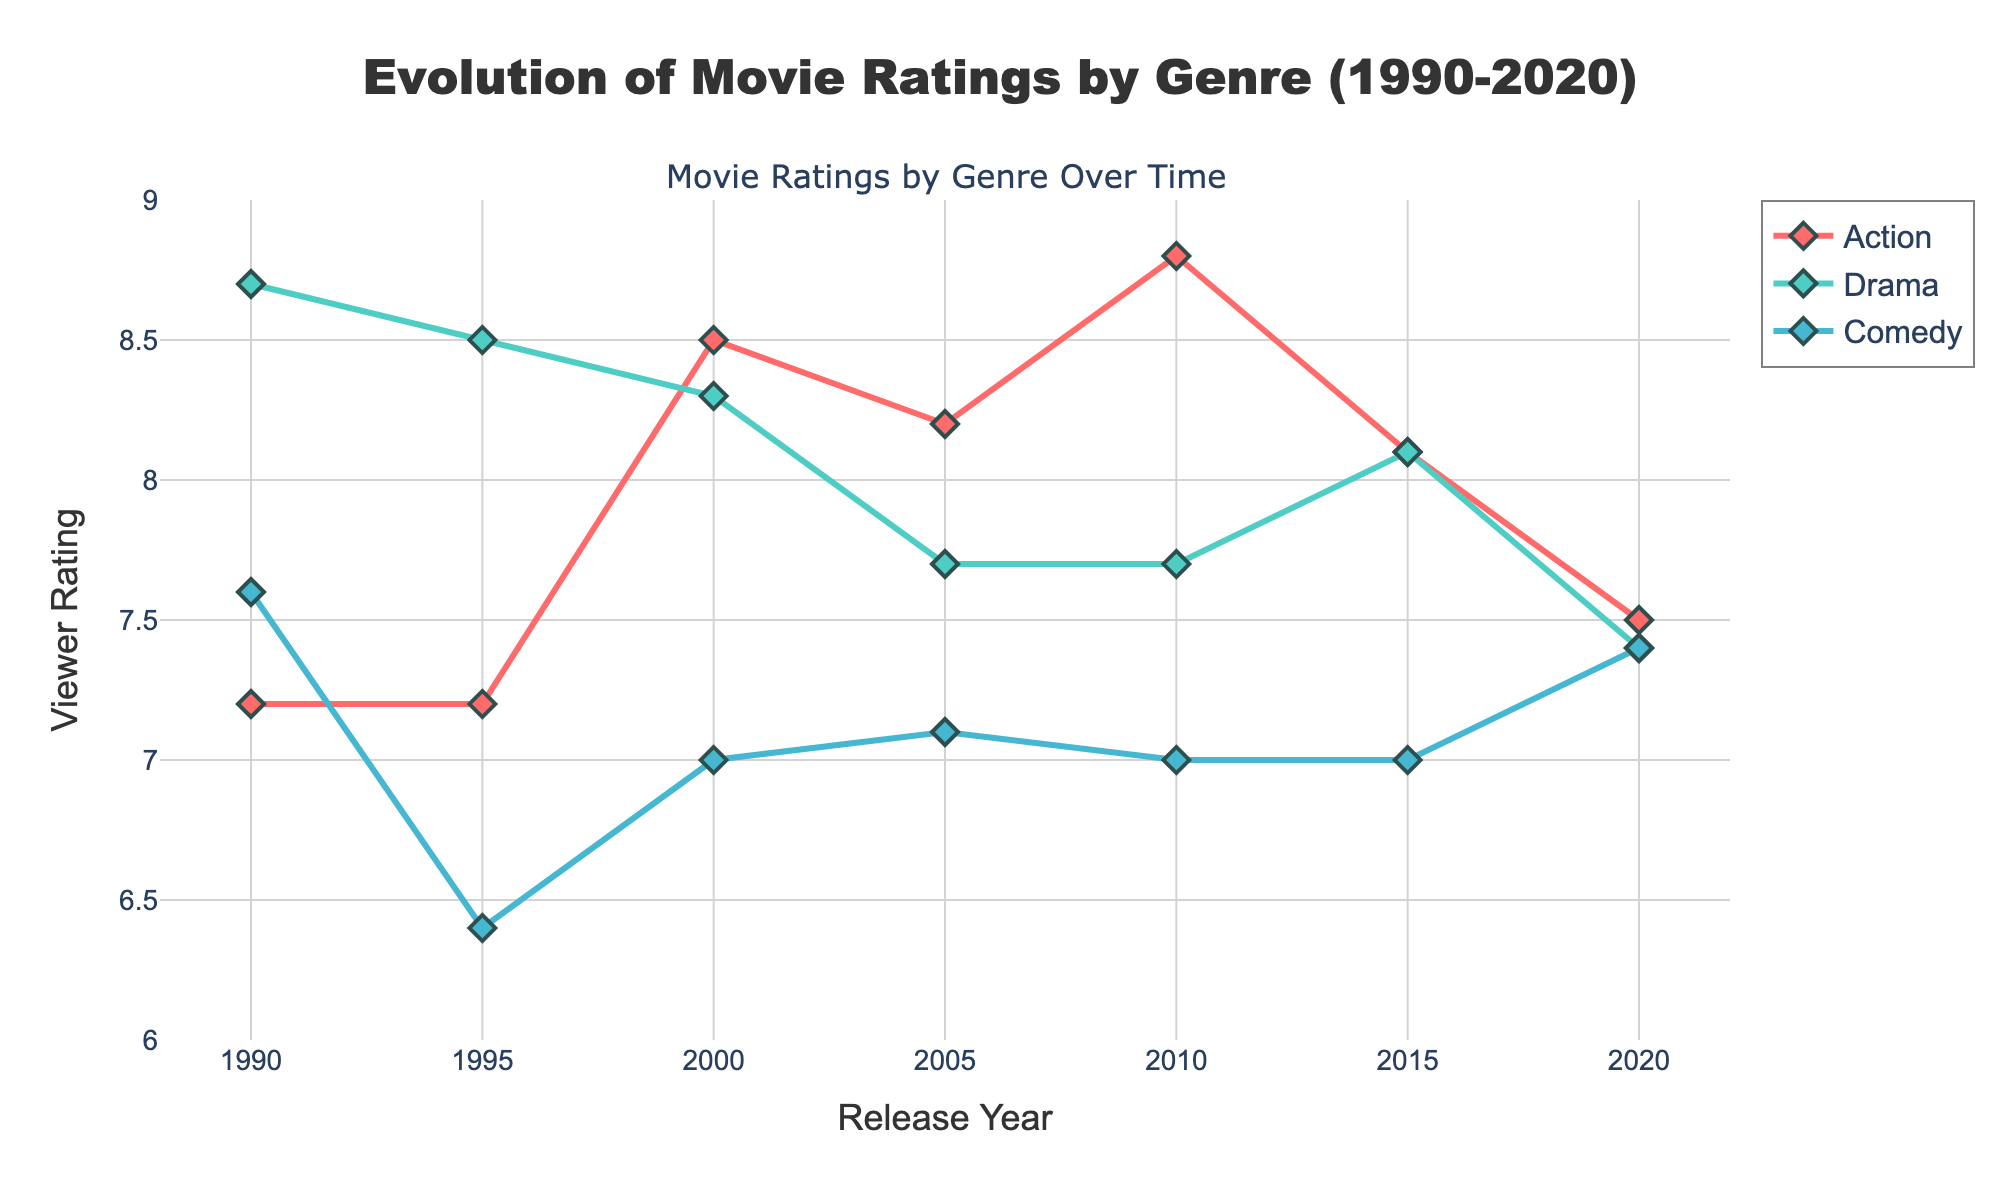What genres are being compared in the plot? The plot shows viewer ratings for three genres: Action, Drama, and Comedy.
Answer: Action, Drama, Comedy Which genre has the highest viewer rating overall? By checking the maximum y-values (viewer ratings) for each genre, Action has the highest rating, with the movie "Inception" at 8.8.
Answer: Action What is the average viewer rating for Drama movies in 2005? Based on the figure, the Drama movies from 2005 are represented by "Brokeback Mountain" with a rating of 7.7. Since there is only one Drama movie from that year, the average rating is 7.7.
Answer: 7.7 Between 1995 and 2020, which genre shows the most consistent viewer ratings, meaning the least variation? By observing the plot, Comedy movies display the least variation in ratings over the years. Their ratings remain around the 7.0 mark consistently.
Answer: Comedy How do Drama movies' ratings in 1990 compare to those in 2020? In 1990, Drama has a rating with "Goodfellas" at 8.7, while in 2020, Drama is represented by "Never Rarely Sometimes Always" with a rating of 7.4. The rating has decreased from 8.7 to 7.4.
Answer: Decreased What is the trend in viewer ratings for Action movies from 1990 to 2020? The viewer ratings for Action movies show a general increase from 1990 ("Die Hard 2" at 7.2) to 2020 ("Tenet" at 7.5), peaking with "Inception" in 2010 at 8.8.
Answer: Generally increasing Which year shows the highest-rated Comedy movie? From the plot, the highest-rated Comedy movie year is 1990, with "Home Alone" rated at 7.6.
Answer: 1990 How many movies are plotted in total for all genres combined? By counting the data points on the plot, there are 2 movies each plotted per year for 6 different years (1990, 1995, 2000, 2005, 2010, 2015, 2020), amounting to a total of 18 movies (6*3=18).
Answer: 18 What is the viewer rating range for Action movies on the plot? The viewer ratings for Action movies range from 7.2 ("Die Hard 2" in 1990 and "GoldenEye" in 1995) to 8.8 ("Inception" in 2010).
Answer: 7.2 to 8.8 Which genre saw the biggest drop in viewer ratings from one year to the next? Observing the plot, Drama movies saw the biggest drop from 1990 ("Goodfellas" at 8.7) to 1995 ("The Usual Suspects" at 8.5), a decrease of 0.2.
Answer: Drama 